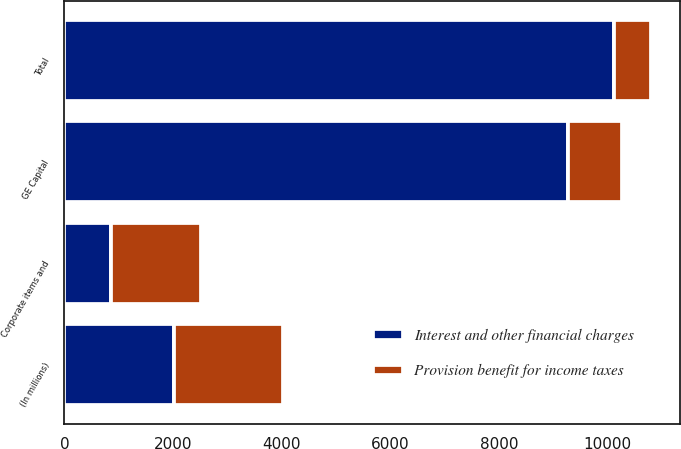<chart> <loc_0><loc_0><loc_500><loc_500><stacked_bar_chart><ecel><fcel>(In millions)<fcel>GE Capital<fcel>Corporate items and<fcel>Total<nl><fcel>Interest and other financial charges<fcel>2013<fcel>9267<fcel>849<fcel>10116<nl><fcel>Provision benefit for income taxes<fcel>2013<fcel>992<fcel>1668<fcel>676<nl></chart> 